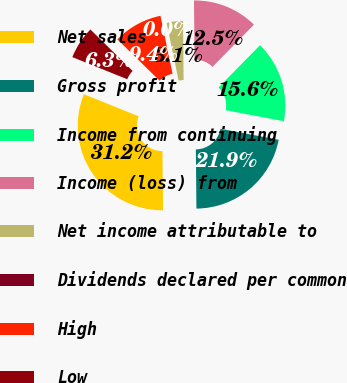<chart> <loc_0><loc_0><loc_500><loc_500><pie_chart><fcel>Net sales<fcel>Gross profit<fcel>Income from continuing<fcel>Income (loss) from<fcel>Net income attributable to<fcel>Dividends declared per common<fcel>High<fcel>Low<nl><fcel>31.24%<fcel>21.87%<fcel>15.62%<fcel>12.5%<fcel>3.13%<fcel>0.0%<fcel>9.38%<fcel>6.25%<nl></chart> 